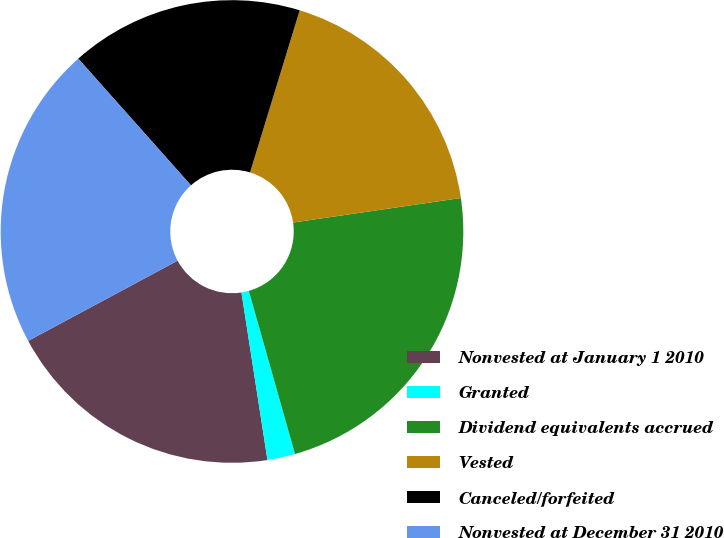Convert chart to OTSL. <chart><loc_0><loc_0><loc_500><loc_500><pie_chart><fcel>Nonvested at January 1 2010<fcel>Granted<fcel>Dividend equivalents accrued<fcel>Vested<fcel>Canceled/forfeited<fcel>Nonvested at December 31 2010<nl><fcel>19.61%<fcel>1.94%<fcel>22.92%<fcel>17.96%<fcel>16.3%<fcel>21.27%<nl></chart> 